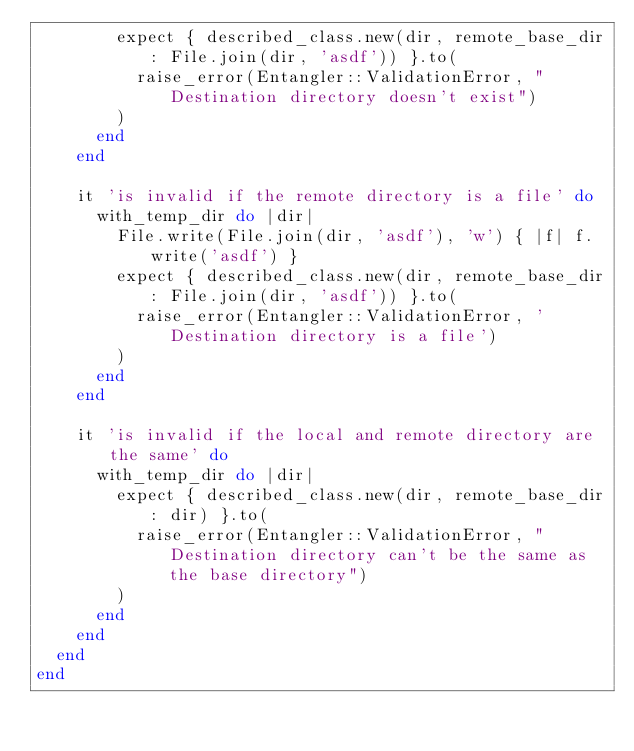<code> <loc_0><loc_0><loc_500><loc_500><_Ruby_>        expect { described_class.new(dir, remote_base_dir: File.join(dir, 'asdf')) }.to(
          raise_error(Entangler::ValidationError, "Destination directory doesn't exist")
        )
      end
    end

    it 'is invalid if the remote directory is a file' do
      with_temp_dir do |dir|
        File.write(File.join(dir, 'asdf'), 'w') { |f| f.write('asdf') }
        expect { described_class.new(dir, remote_base_dir: File.join(dir, 'asdf')) }.to(
          raise_error(Entangler::ValidationError, 'Destination directory is a file')
        )
      end
    end

    it 'is invalid if the local and remote directory are the same' do
      with_temp_dir do |dir|
        expect { described_class.new(dir, remote_base_dir: dir) }.to(
          raise_error(Entangler::ValidationError, "Destination directory can't be the same as the base directory")
        )
      end
    end
  end
end
</code> 